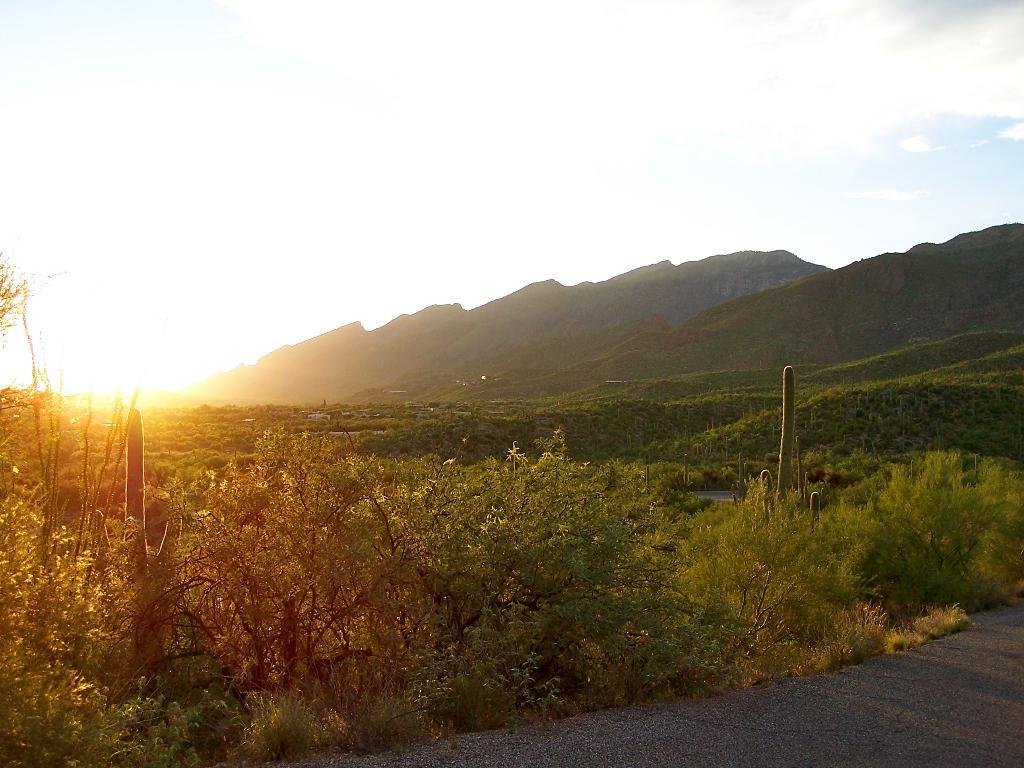Where was the picture taken? The picture was clicked outside. What can be seen in the foreground of the image? There is ground visible in the foreground, and green grass and plants are present. What is visible in the background of the image? The sky is visible in the background, and hills are present. What is the source of light in the image? Sunlight is visible in the image. How does the fireman compare to the apple in the image? There is no fireman or apple present in the image. 